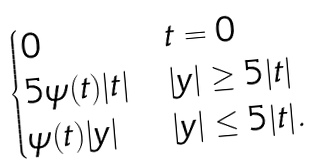Convert formula to latex. <formula><loc_0><loc_0><loc_500><loc_500>\begin{cases} 0 & t = 0 \\ 5 \psi ( t ) | t | & | y | \geq 5 | t | \\ \psi ( t ) | y | & | y | \leq 5 | t | . \end{cases}</formula> 